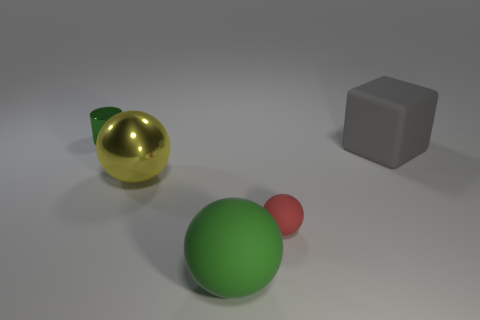Subtract all matte balls. How many balls are left? 1 Add 4 large gray objects. How many objects exist? 9 Subtract all balls. How many objects are left? 2 Subtract all yellow balls. How many balls are left? 2 Add 4 large green rubber things. How many large green rubber things are left? 5 Add 4 small cyan shiny cubes. How many small cyan shiny cubes exist? 4 Subtract 0 brown blocks. How many objects are left? 5 Subtract all green spheres. Subtract all yellow cylinders. How many spheres are left? 2 Subtract all large purple objects. Subtract all green shiny objects. How many objects are left? 4 